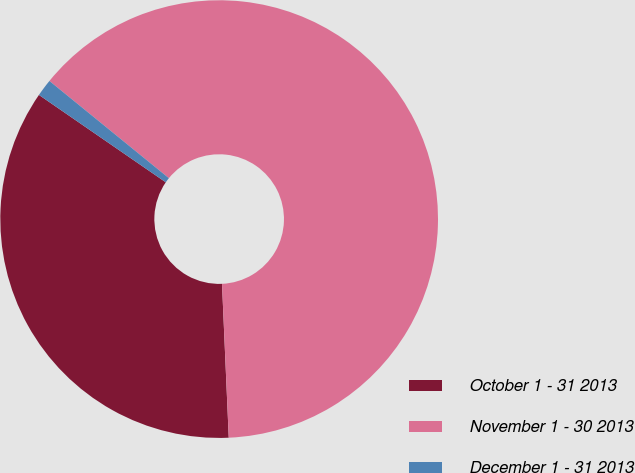Convert chart. <chart><loc_0><loc_0><loc_500><loc_500><pie_chart><fcel>October 1 - 31 2013<fcel>November 1 - 30 2013<fcel>December 1 - 31 2013<nl><fcel>35.3%<fcel>63.43%<fcel>1.27%<nl></chart> 